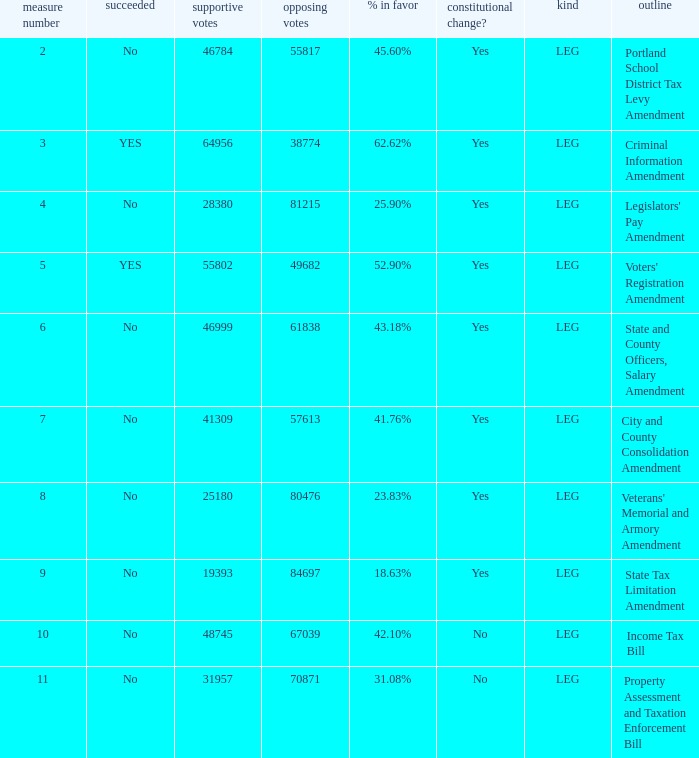HOw many no votes were there when there were 45.60% yes votes 55817.0. 